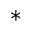Convert formula to latex. <formula><loc_0><loc_0><loc_500><loc_500>*</formula> 